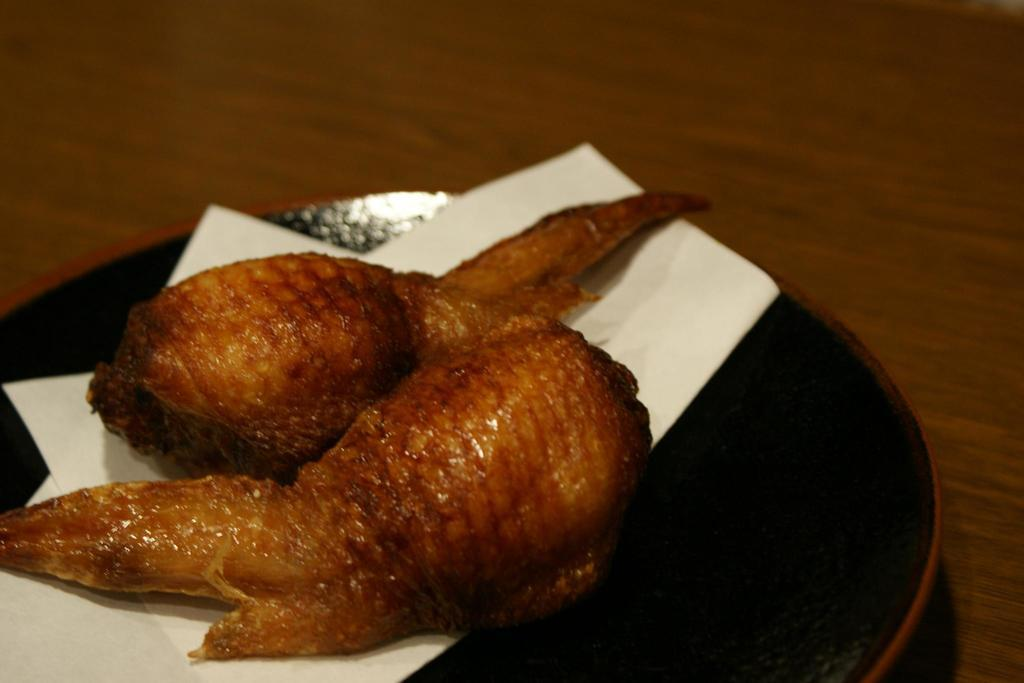What is placed on the surface in the image? There is food placed in a plate on the surface. Can you describe the food in the plate? The provided facts do not specify the type of food in the plate. Where is the plate located? The plate is kept on a surface. What type of birthday scene is depicted in the image? There is no birthday scene present in the image; it only shows a plate with food on a surface. 